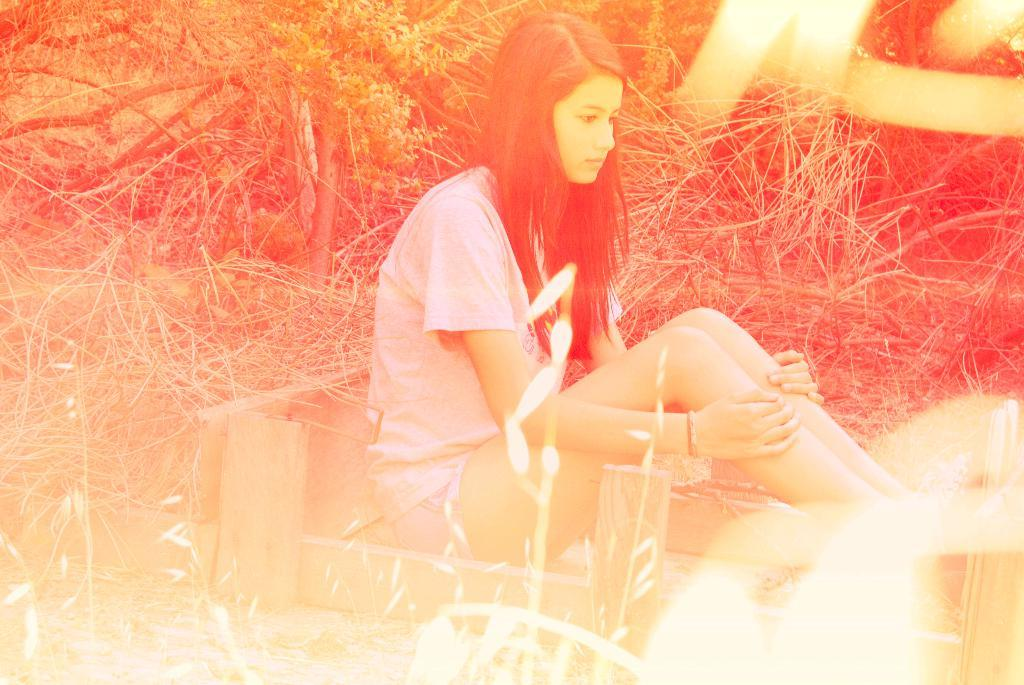What is the girl in the image doing? The girl is sitting on the ground in the image. What is on the ground around the girl? There are wooden planks on the ground around her. What can be seen in the background of the image? Plants and trees are visible in the background of the image. Has the image been altered in any way? Yes, the image has been edited. How many cows are visible in the image? There are no cows present in the image. What type of toad can be seen hopping near the girl in the image? There is no toad present in the image. 